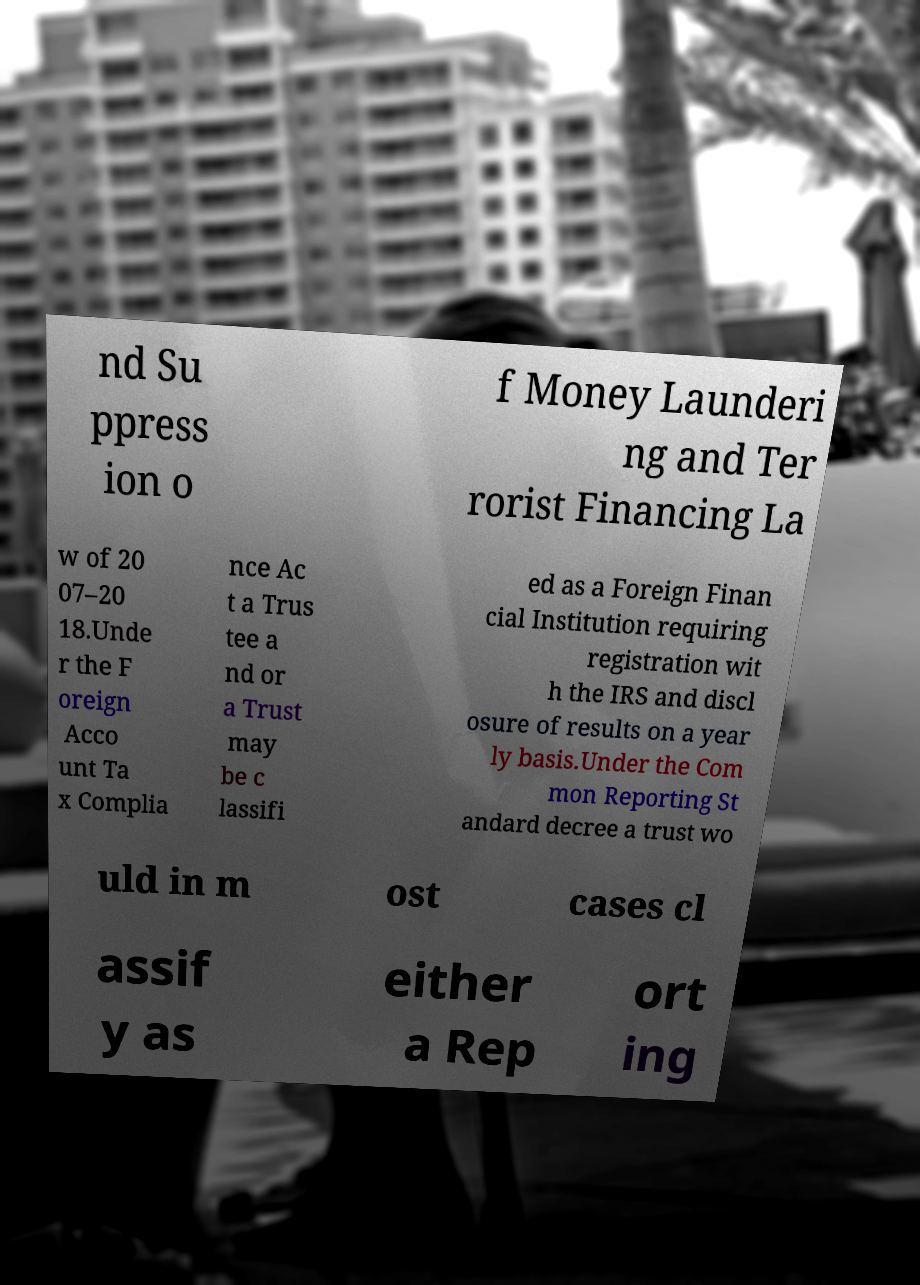What messages or text are displayed in this image? I need them in a readable, typed format. nd Su ppress ion o f Money Launderi ng and Ter rorist Financing La w of 20 07–20 18.Unde r the F oreign Acco unt Ta x Complia nce Ac t a Trus tee a nd or a Trust may be c lassifi ed as a Foreign Finan cial Institution requiring registration wit h the IRS and discl osure of results on a year ly basis.Under the Com mon Reporting St andard decree a trust wo uld in m ost cases cl assif y as either a Rep ort ing 